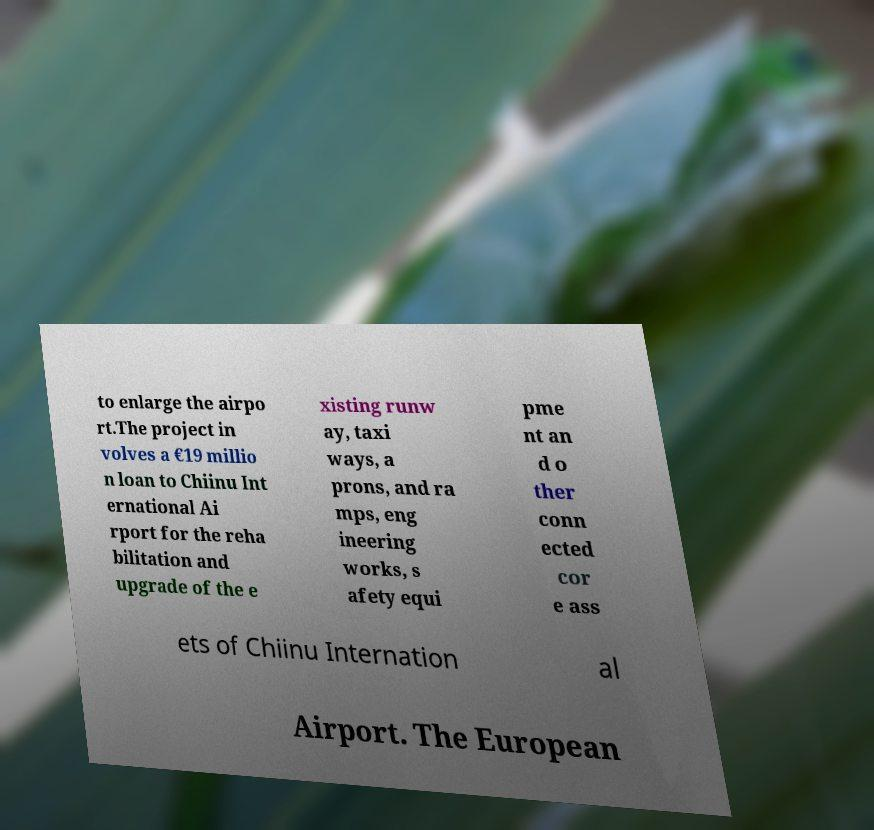For documentation purposes, I need the text within this image transcribed. Could you provide that? to enlarge the airpo rt.The project in volves a €19 millio n loan to Chiinu Int ernational Ai rport for the reha bilitation and upgrade of the e xisting runw ay, taxi ways, a prons, and ra mps, eng ineering works, s afety equi pme nt an d o ther conn ected cor e ass ets of Chiinu Internation al Airport. The European 